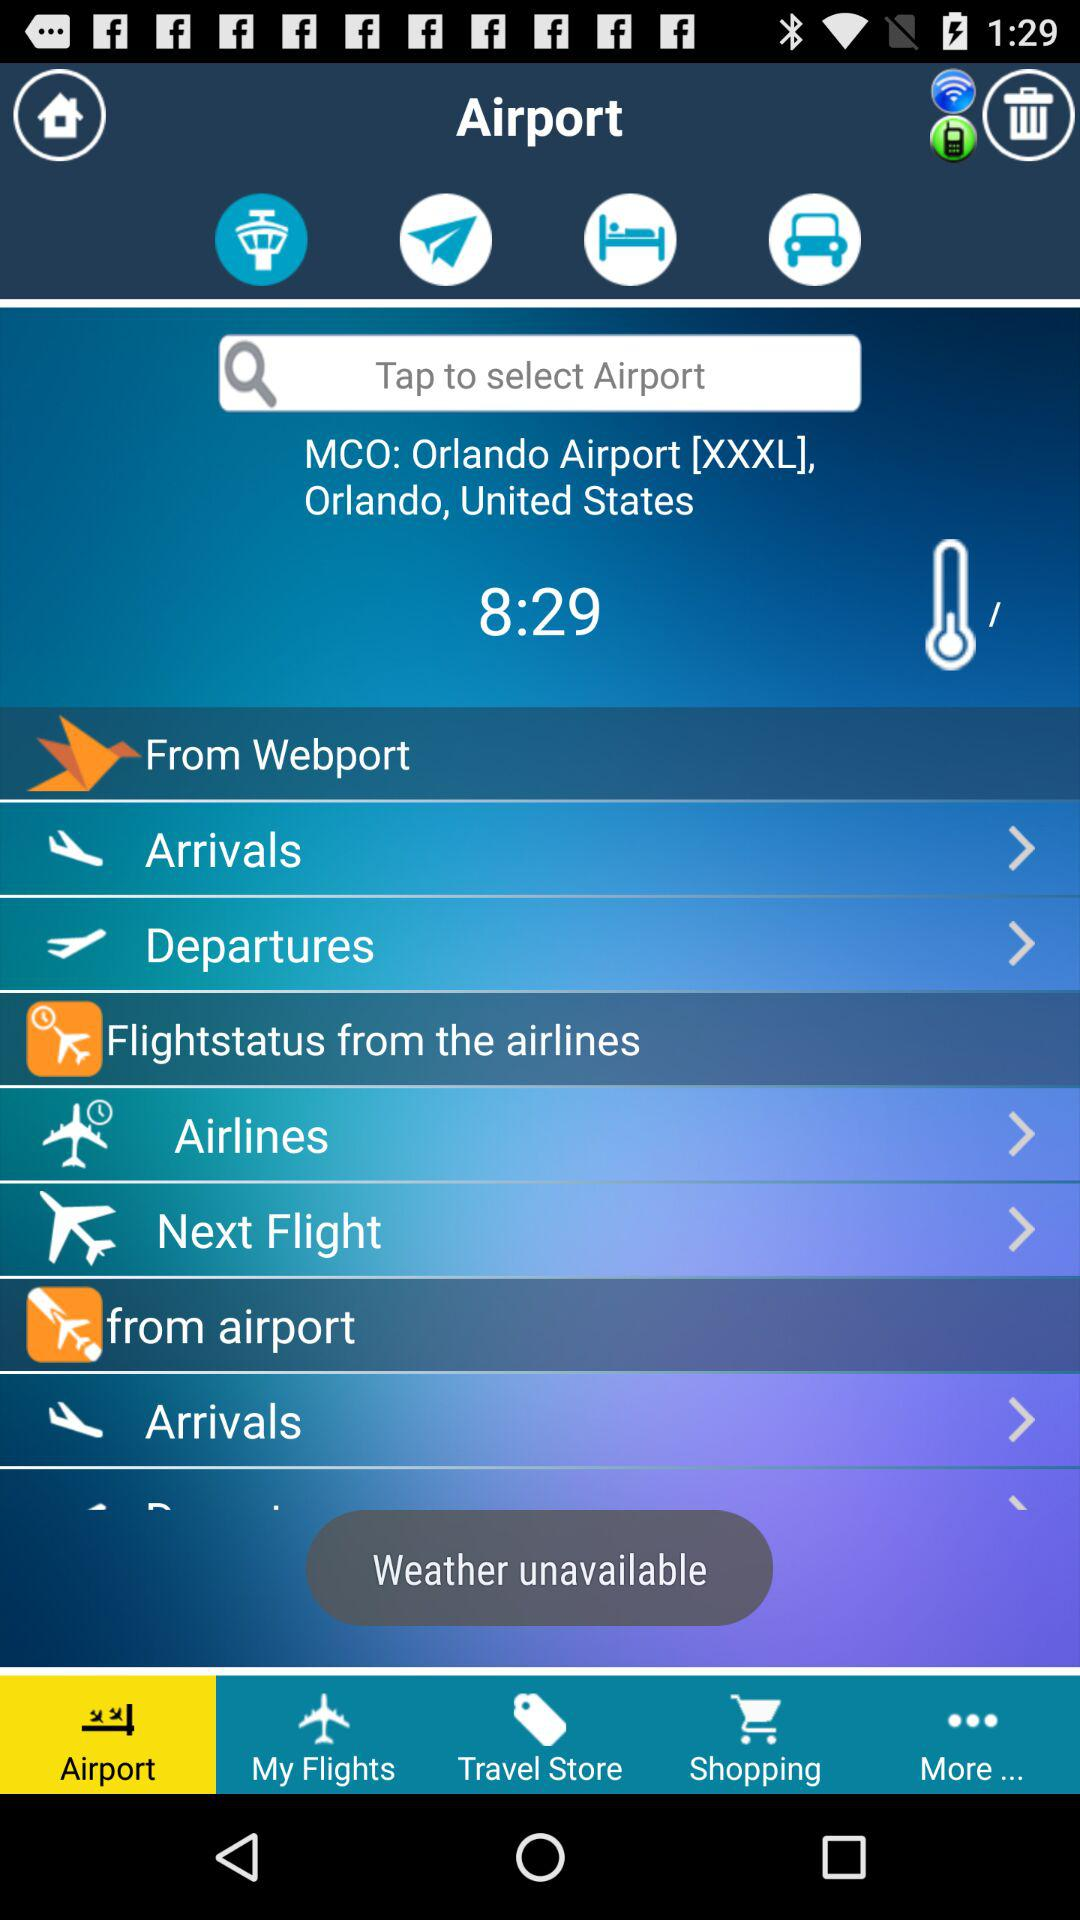How's the weather? The weather is unavailable. 